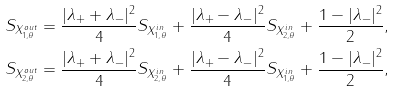Convert formula to latex. <formula><loc_0><loc_0><loc_500><loc_500>S _ { X _ { 1 , \theta } ^ { o u t } } & = \frac { | \lambda _ { + } + \lambda _ { - } | ^ { 2 } } { 4 } S _ { X _ { 1 , \theta } ^ { i n } } + \frac { | \lambda _ { + } - \lambda _ { - } | ^ { 2 } } { 4 } S _ { X _ { 2 , \theta } ^ { i n } } + \frac { 1 - | \lambda _ { - } | ^ { 2 } } { 2 } , \\ S _ { X _ { 2 , \theta } ^ { o u t } } & = \frac { | \lambda _ { + } + \lambda _ { - } | ^ { 2 } } { 4 } S _ { X _ { 2 , \theta } ^ { i n } } + \frac { | \lambda _ { + } - \lambda _ { - } | ^ { 2 } } { 4 } S _ { X _ { 1 , \theta } ^ { i n } } + \frac { 1 - | \lambda _ { - } | ^ { 2 } } { 2 } ,</formula> 